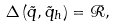Convert formula to latex. <formula><loc_0><loc_0><loc_500><loc_500>\Delta \left ( \tilde { q } , \tilde { q } _ { h } \right ) = \mathcal { R } ,</formula> 